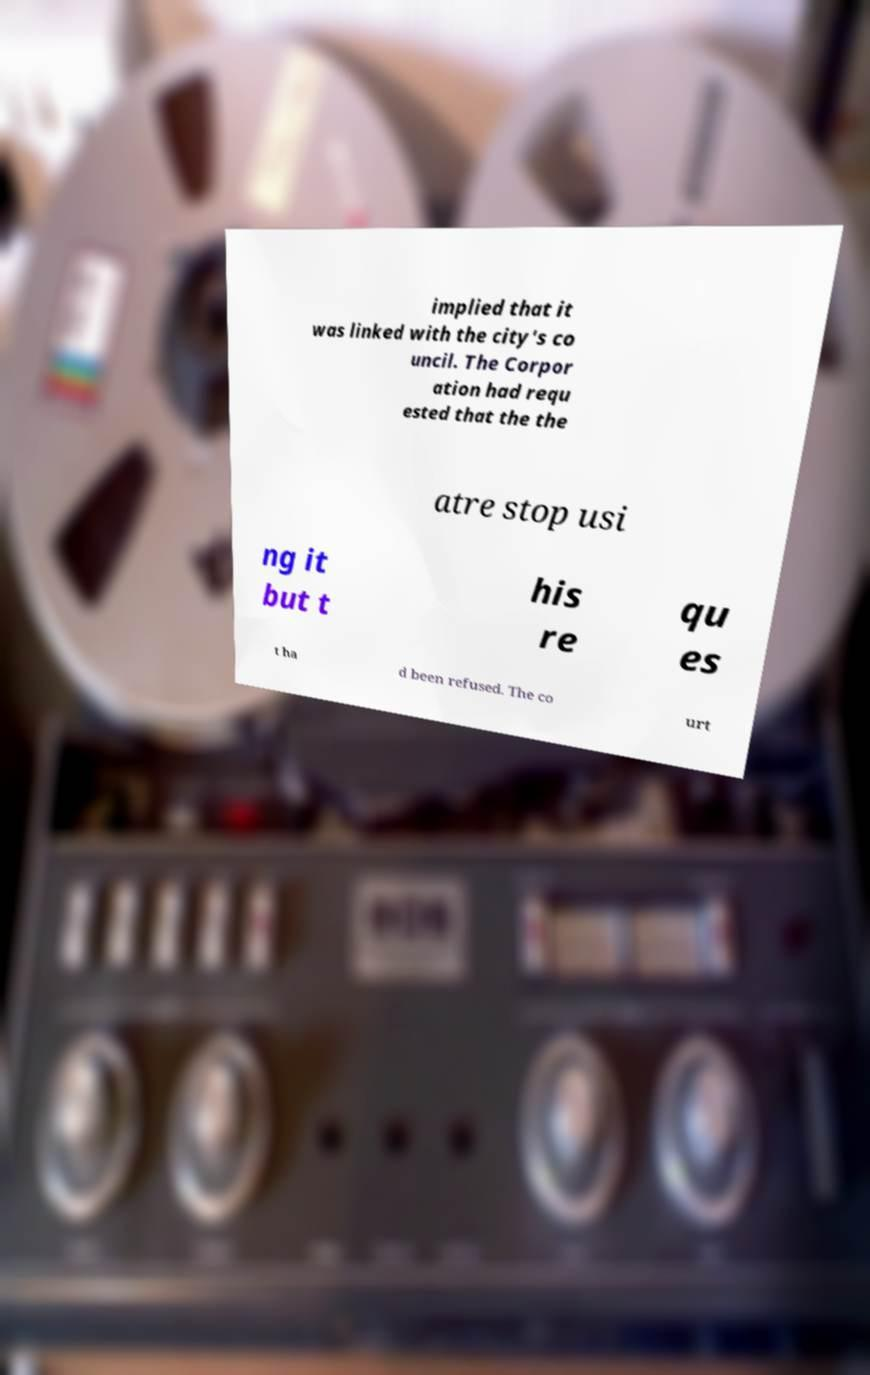What messages or text are displayed in this image? I need them in a readable, typed format. implied that it was linked with the city's co uncil. The Corpor ation had requ ested that the the atre stop usi ng it but t his re qu es t ha d been refused. The co urt 